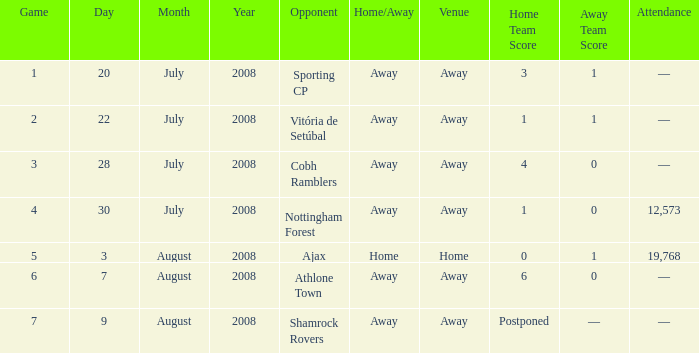What is the result on 20 July 2008? 3–1. 